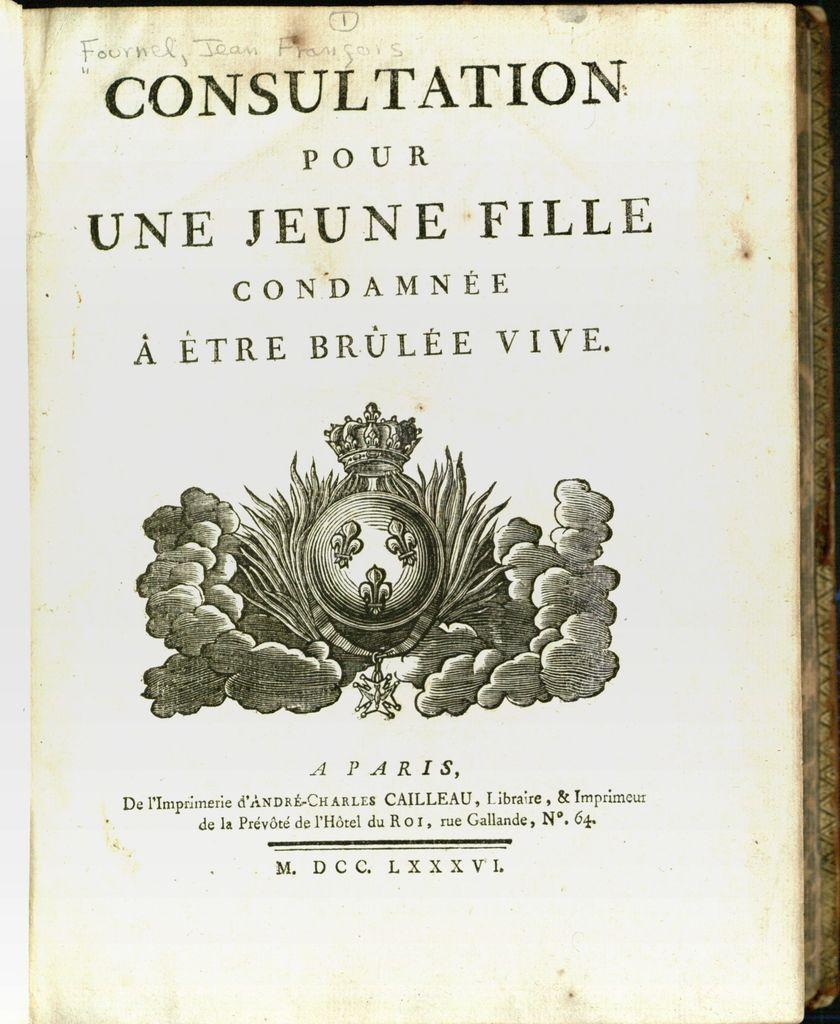What is present on the paper in the image? There is a paper in the image, and it has text on it. Is there any artwork on the paper? Yes, there is a painted image on the paper. What type of polish is being applied to the paper in the image? There is no polish being applied to the paper in the image; it has text and a painted image on it. 